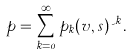Convert formula to latex. <formula><loc_0><loc_0><loc_500><loc_500>p = \sum _ { k = 0 } ^ { \infty } p _ { k } ( v , s ) \psi ^ { k } \, .</formula> 